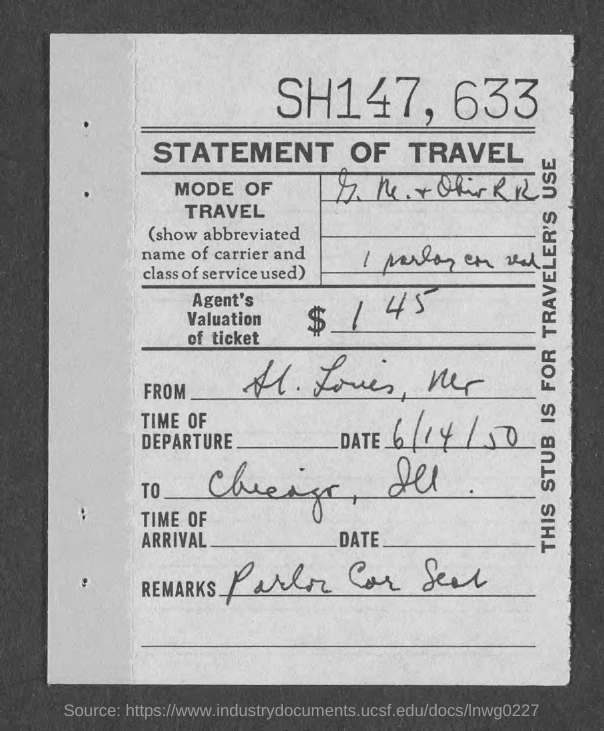What is the document about?
Make the answer very short. Statement of Travel. What is the number written at the top of the page?
Provide a succinct answer. SH147, 633. What is the date given?
Provide a succinct answer. 6/14/50. 